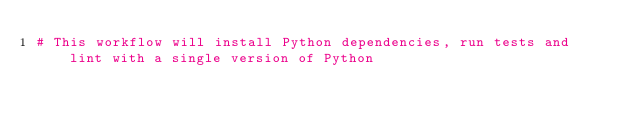Convert code to text. <code><loc_0><loc_0><loc_500><loc_500><_YAML_># This workflow will install Python dependencies, run tests and lint with a single version of Python</code> 